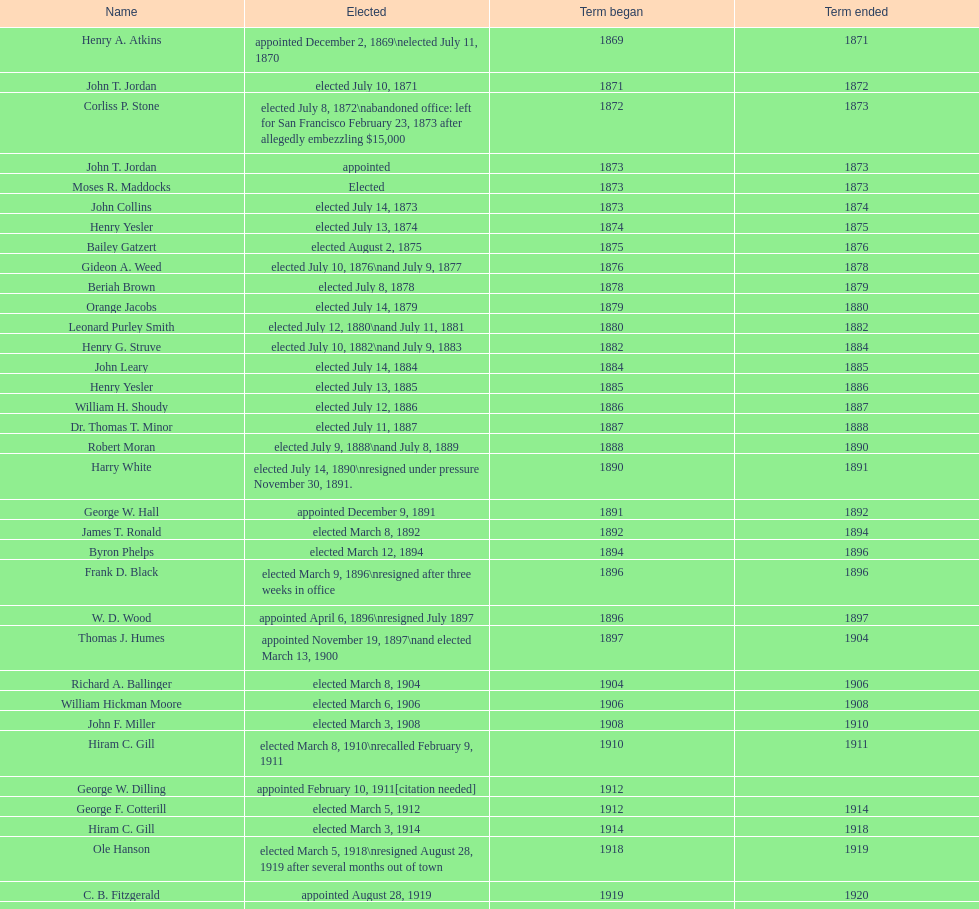Who commenced their term during 1890? Harry White. Could you help me parse every detail presented in this table? {'header': ['Name', 'Elected', 'Term began', 'Term ended'], 'rows': [['Henry A. Atkins', 'appointed December 2, 1869\\nelected July 11, 1870', '1869', '1871'], ['John T. Jordan', 'elected July 10, 1871', '1871', '1872'], ['Corliss P. Stone', 'elected July 8, 1872\\nabandoned office: left for San Francisco February 23, 1873 after allegedly embezzling $15,000', '1872', '1873'], ['John T. Jordan', 'appointed', '1873', '1873'], ['Moses R. Maddocks', 'Elected', '1873', '1873'], ['John Collins', 'elected July 14, 1873', '1873', '1874'], ['Henry Yesler', 'elected July 13, 1874', '1874', '1875'], ['Bailey Gatzert', 'elected August 2, 1875', '1875', '1876'], ['Gideon A. Weed', 'elected July 10, 1876\\nand July 9, 1877', '1876', '1878'], ['Beriah Brown', 'elected July 8, 1878', '1878', '1879'], ['Orange Jacobs', 'elected July 14, 1879', '1879', '1880'], ['Leonard Purley Smith', 'elected July 12, 1880\\nand July 11, 1881', '1880', '1882'], ['Henry G. Struve', 'elected July 10, 1882\\nand July 9, 1883', '1882', '1884'], ['John Leary', 'elected July 14, 1884', '1884', '1885'], ['Henry Yesler', 'elected July 13, 1885', '1885', '1886'], ['William H. Shoudy', 'elected July 12, 1886', '1886', '1887'], ['Dr. Thomas T. Minor', 'elected July 11, 1887', '1887', '1888'], ['Robert Moran', 'elected July 9, 1888\\nand July 8, 1889', '1888', '1890'], ['Harry White', 'elected July 14, 1890\\nresigned under pressure November 30, 1891.', '1890', '1891'], ['George W. Hall', 'appointed December 9, 1891', '1891', '1892'], ['James T. Ronald', 'elected March 8, 1892', '1892', '1894'], ['Byron Phelps', 'elected March 12, 1894', '1894', '1896'], ['Frank D. Black', 'elected March 9, 1896\\nresigned after three weeks in office', '1896', '1896'], ['W. D. Wood', 'appointed April 6, 1896\\nresigned July 1897', '1896', '1897'], ['Thomas J. Humes', 'appointed November 19, 1897\\nand elected March 13, 1900', '1897', '1904'], ['Richard A. Ballinger', 'elected March 8, 1904', '1904', '1906'], ['William Hickman Moore', 'elected March 6, 1906', '1906', '1908'], ['John F. Miller', 'elected March 3, 1908', '1908', '1910'], ['Hiram C. Gill', 'elected March 8, 1910\\nrecalled February 9, 1911', '1910', '1911'], ['George W. Dilling', 'appointed February 10, 1911[citation needed]', '1912', ''], ['George F. Cotterill', 'elected March 5, 1912', '1912', '1914'], ['Hiram C. Gill', 'elected March 3, 1914', '1914', '1918'], ['Ole Hanson', 'elected March 5, 1918\\nresigned August 28, 1919 after several months out of town', '1918', '1919'], ['C. B. Fitzgerald', 'appointed August 28, 1919', '1919', '1920'], ['Hugh M. Caldwell', 'elected March 2, 1920', '1920', '1922'], ['Edwin J. Brown', 'elected May 2, 1922\\nand March 4, 1924', '1922', '1926'], ['Bertha Knight Landes', 'elected March 9, 1926', '1926', '1928'], ['Frank E. Edwards', 'elected March 6, 1928\\nand March 4, 1930\\nrecalled July 13, 1931', '1928', '1931'], ['Robert H. Harlin', 'appointed July 14, 1931', '1931', '1932'], ['John F. Dore', 'elected March 8, 1932', '1932', '1934'], ['Charles L. Smith', 'elected March 6, 1934', '1934', '1936'], ['John F. Dore', 'elected March 3, 1936\\nbecame gravely ill and was relieved of office April 13, 1938, already a lame duck after the 1938 election. He died five days later.', '1936', '1938'], ['Arthur B. Langlie', "elected March 8, 1938\\nappointed to take office early, April 27, 1938, after Dore's death.\\nelected March 5, 1940\\nresigned January 11, 1941, to become Governor of Washington", '1938', '1941'], ['John E. Carroll', 'appointed January 27, 1941', '1941', '1941'], ['Earl Millikin', 'elected March 4, 1941', '1941', '1942'], ['William F. Devin', 'elected March 3, 1942, March 7, 1944, March 5, 1946, and March 2, 1948', '1942', '1952'], ['Allan Pomeroy', 'elected March 4, 1952', '1952', '1956'], ['Gordon S. Clinton', 'elected March 6, 1956\\nand March 8, 1960', '1956', '1964'], ["James d'Orma Braman", 'elected March 10, 1964\\nresigned March 23, 1969, to accept an appointment as an Assistant Secretary in the Department of Transportation in the Nixon administration.', '1964', '1969'], ['Floyd C. Miller', 'appointed March 23, 1969', '1969', '1969'], ['Wesley C. Uhlman', 'elected November 4, 1969\\nand November 6, 1973\\nsurvived recall attempt on July 1, 1975', 'December 1, 1969', 'January 1, 1978'], ['Charles Royer', 'elected November 8, 1977, November 3, 1981, and November 5, 1985', 'January 1, 1978', 'January 1, 1990'], ['Norman B. Rice', 'elected November 7, 1989', 'January 1, 1990', 'January 1, 1998'], ['Paul Schell', 'elected November 4, 1997', 'January 1, 1998', 'January 1, 2002'], ['Gregory J. Nickels', 'elected November 6, 2001\\nand November 8, 2005', 'January 1, 2002', 'January 1, 2010'], ['Michael McGinn', 'elected November 3, 2009', 'January 1, 2010', 'January 1, 2014'], ['Ed Murray', 'elected November 5, 2013', 'January 1, 2014', 'present']]} 